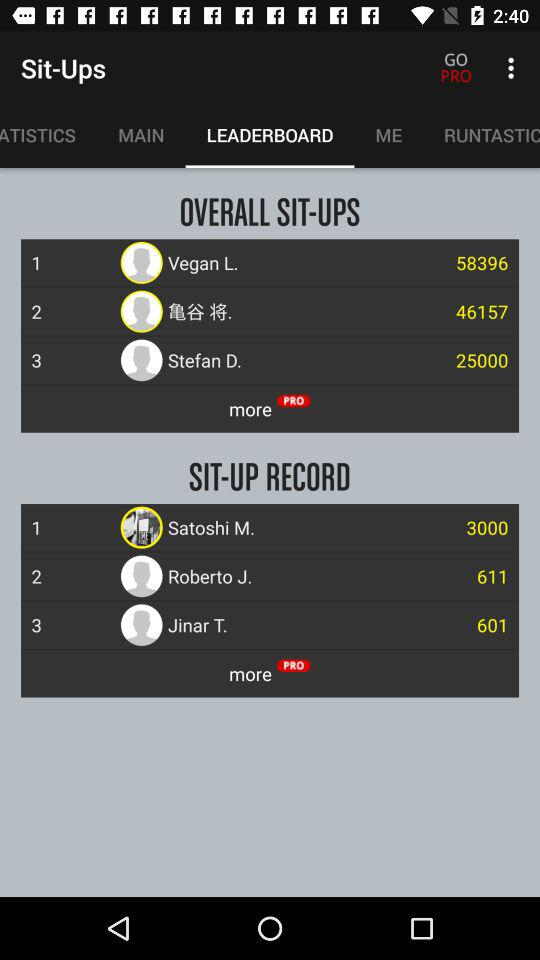Who has the first rank in "OVERALL SIT-UPS"? The first rank in "OVERALL SIT-UPS" goes to Vegan L.. 